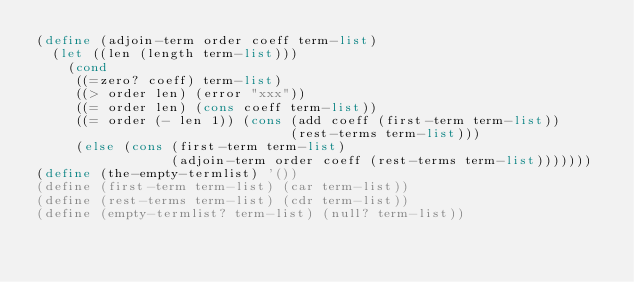<code> <loc_0><loc_0><loc_500><loc_500><_Scheme_>(define (adjoin-term order coeff term-list)
  (let ((len (length term-list)))
    (cond
     ((=zero? coeff) term-list)
     ((> order len) (error "xxx"))
     ((= order len) (cons coeff term-list))
     ((= order (- len 1)) (cons (add coeff (first-term term-list))
                                (rest-terms term-list)))
     (else (cons (first-term term-list)
                 (adjoin-term order coeff (rest-terms term-list)))))))
(define (the-empty-termlist) '())
(define (first-term term-list) (car term-list))
(define (rest-terms term-list) (cdr term-list))
(define (empty-termlist? term-list) (null? term-list))
</code> 